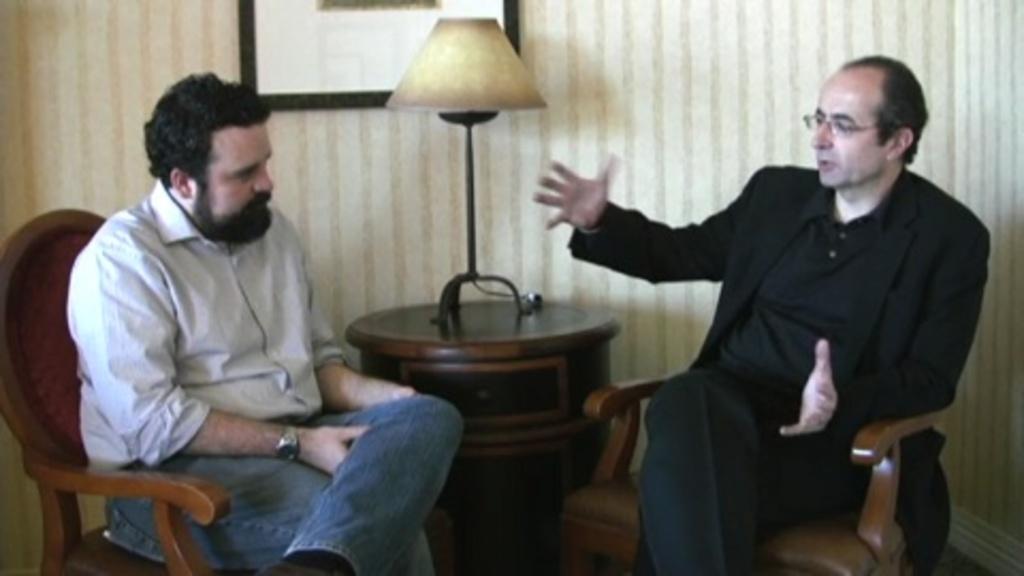Can you describe this image briefly? There are two men sitting in the chair, in front of each other and talking. There is a lamp placed on the table. In the background, there is a photo frame attached to the wall. 